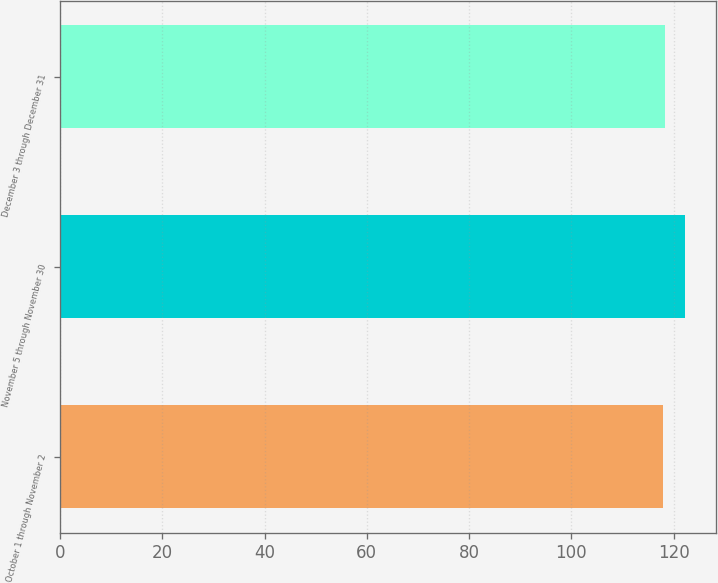<chart> <loc_0><loc_0><loc_500><loc_500><bar_chart><fcel>October 1 through November 2<fcel>November 5 through November 30<fcel>December 3 through December 31<nl><fcel>117.99<fcel>122.28<fcel>118.42<nl></chart> 